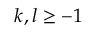Convert formula to latex. <formula><loc_0><loc_0><loc_500><loc_500>k , l \geq - 1</formula> 